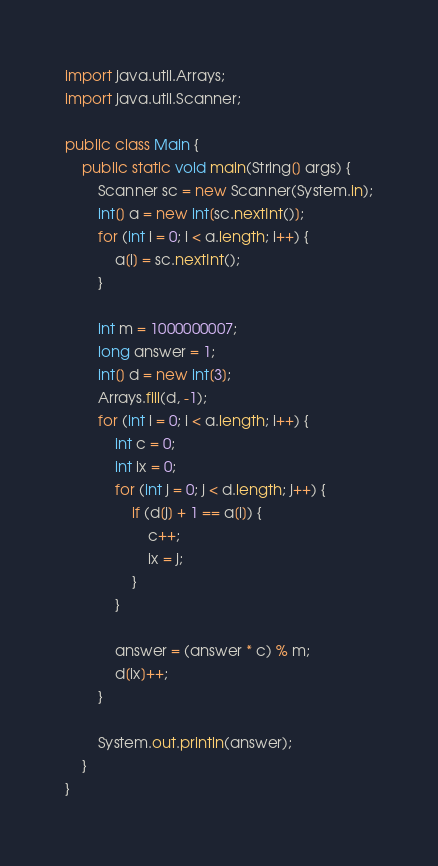<code> <loc_0><loc_0><loc_500><loc_500><_Java_>import java.util.Arrays;
import java.util.Scanner;

public class Main {
	public static void main(String[] args) {
		Scanner sc = new Scanner(System.in);
		int[] a = new int[sc.nextInt()];
		for (int i = 0; i < a.length; i++) {
			a[i] = sc.nextInt();
		}

		int m = 1000000007;
		long answer = 1;
		int[] d = new int[3];
		Arrays.fill(d, -1);
		for (int i = 0; i < a.length; i++) {
			int c = 0;
			int ix = 0;
			for (int j = 0; j < d.length; j++) {
				if (d[j] + 1 == a[i]) {
					c++;
					ix = j;
				}
			}

			answer = (answer * c) % m;
			d[ix]++;
		}

		System.out.println(answer);
	}
}
</code> 